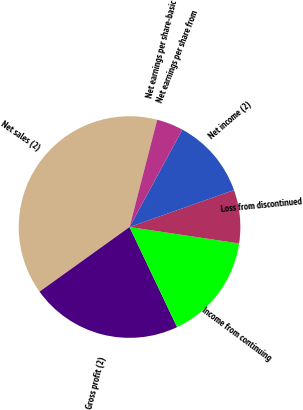Convert chart to OTSL. <chart><loc_0><loc_0><loc_500><loc_500><pie_chart><fcel>Net sales (2)<fcel>Gross profit (2)<fcel>Income from continuing<fcel>Loss from discontinued<fcel>Net income (2)<fcel>Net earnings per share from<fcel>Net earnings per share-basic<nl><fcel>38.92%<fcel>22.15%<fcel>15.57%<fcel>7.78%<fcel>11.68%<fcel>3.89%<fcel>0.0%<nl></chart> 